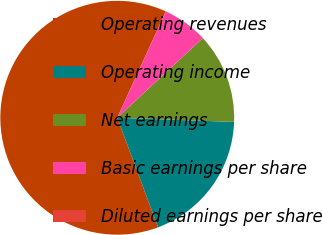Convert chart to OTSL. <chart><loc_0><loc_0><loc_500><loc_500><pie_chart><fcel>Operating revenues<fcel>Operating income<fcel>Net earnings<fcel>Basic earnings per share<fcel>Diluted earnings per share<nl><fcel>62.5%<fcel>18.75%<fcel>12.5%<fcel>6.25%<fcel>0.0%<nl></chart> 